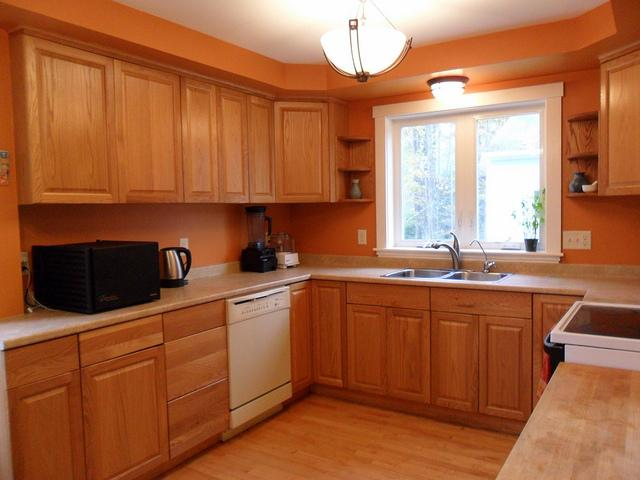What is the black appliance by the corner called? blender 